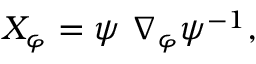Convert formula to latex. <formula><loc_0><loc_0><loc_500><loc_500>X _ { \varphi } = \psi \ \nabla _ { \varphi } \psi ^ { - 1 } ,</formula> 